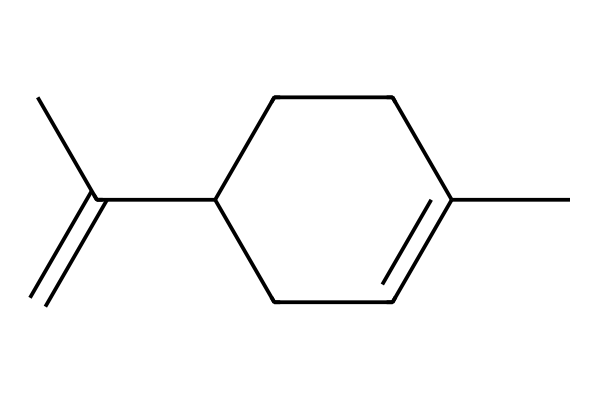What is the molecular formula of limonene? To derive the molecular formula, we determine the number of carbon (C) and hydrogen (H) atoms in the SMILES representation. The structure indicates there are 10 carbon atoms and 16 hydrogen atoms. Therefore, the molecular formula is C10H16.
Answer: C10H16 How many rings are present in limonene's structure? By analyzing the SMILES, we see the presence of 'C1=' indicating a cyclic part of the structure. Counting 'C1' indicates the presence of one cyclic structure, confirming that there is one ring in limonene.
Answer: 1 What type of compound is limonene classified as? Limonene has a specific arrangement and structure characteristic of terpenes, and it possesses a distinct smell, often associated with citrus fruits, leading to its classification as a monoterpene.
Answer: monoterpene What type of functional group is primarily present in limonene? Examining the structure shows a carbon-carbon double bond (C=C) but no other distinct functional groups, highlighting a high presence of aliphatic unsaturation typical of hydrocarbons. Thus, it primarily features aliphatic unsaturation.
Answer: aliphatic unsaturation How many double bonds are in the limonene structure? Inspecting the bonds in the structure represented by the SMILES reveals one C=C double bond after analyzing the connections, indicating that there is exactly one double bond.
Answer: 1 What aspect of its structure gives limonene its characteristic aroma? Limonene has a specific arrangement of carbon and double bonds which allows volatility and interaction with the olfactory system, causing its unique citrus aroma. The broad carbon chain and the presence of a double bond contribute to its fragrance.
Answer: carbon chain and double bond 